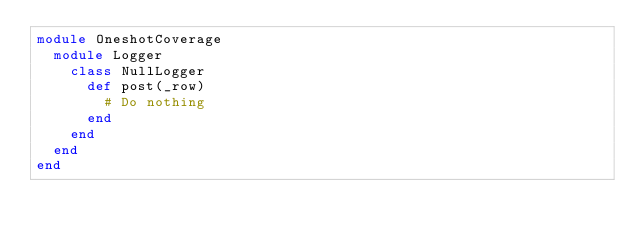Convert code to text. <code><loc_0><loc_0><loc_500><loc_500><_Ruby_>module OneshotCoverage
  module Logger
    class NullLogger
      def post(_row)
        # Do nothing
      end
    end
  end
end
</code> 